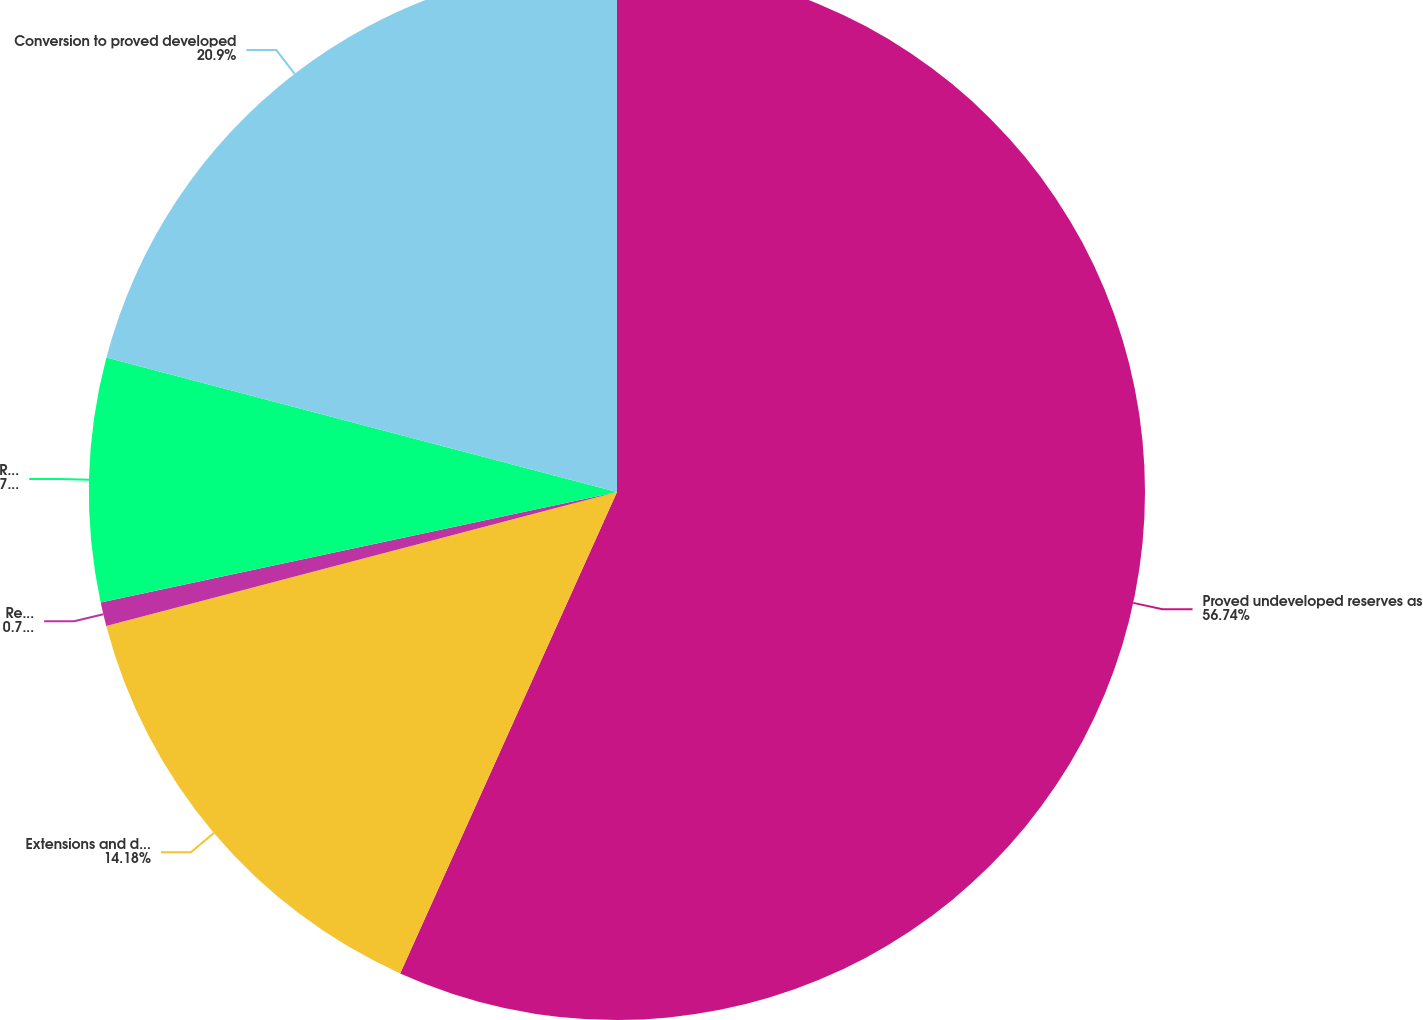Convert chart to OTSL. <chart><loc_0><loc_0><loc_500><loc_500><pie_chart><fcel>Proved undeveloped reserves as<fcel>Extensions and discoveries<fcel>Revisions due to prices<fcel>Revisions other than price<fcel>Conversion to proved developed<nl><fcel>56.73%<fcel>14.18%<fcel>0.73%<fcel>7.45%<fcel>20.9%<nl></chart> 